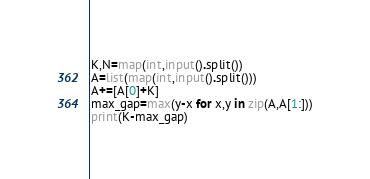<code> <loc_0><loc_0><loc_500><loc_500><_Python_>K,N=map(int,input().split())
A=list(map(int,input().split()))
A+=[A[0]+K]
max_gap=max(y-x for x,y in zip(A,A[1:]))
print(K-max_gap)</code> 